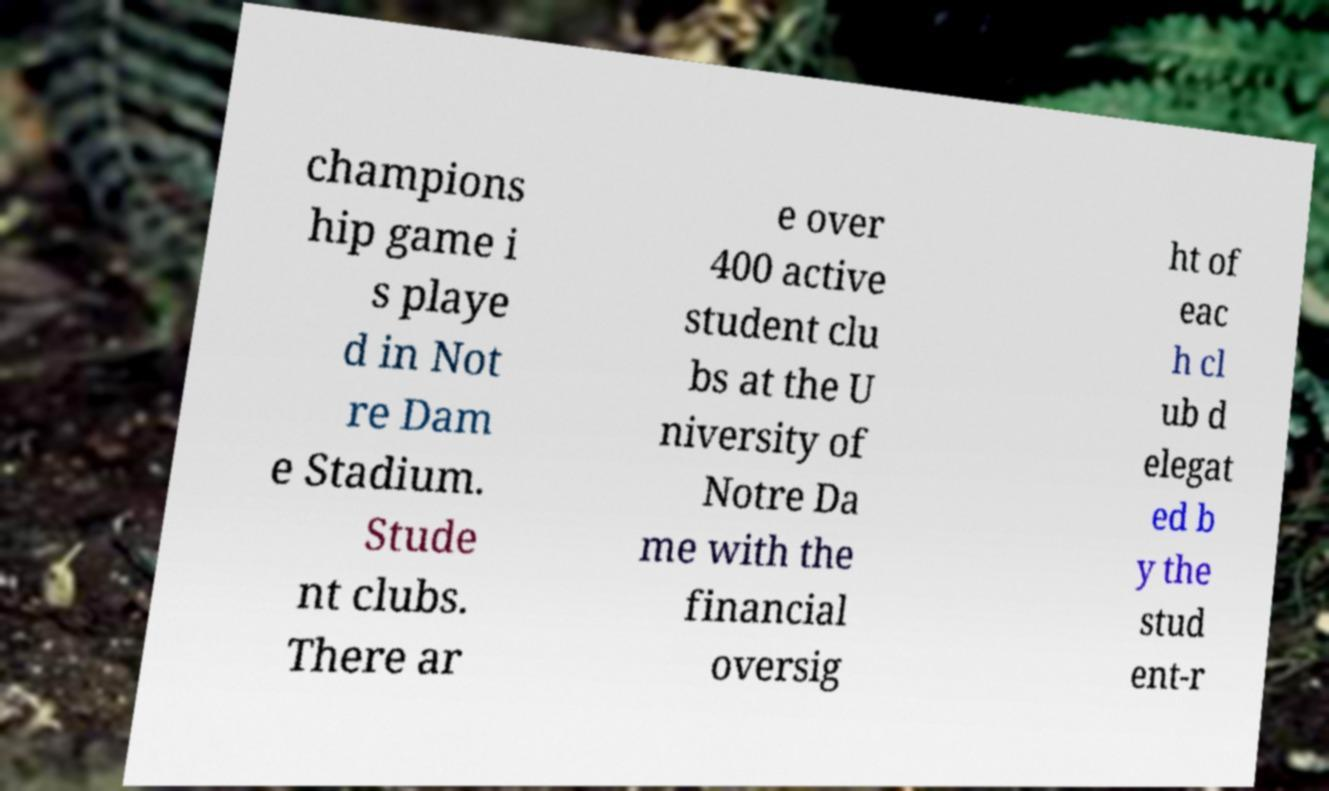Please identify and transcribe the text found in this image. champions hip game i s playe d in Not re Dam e Stadium. Stude nt clubs. There ar e over 400 active student clu bs at the U niversity of Notre Da me with the financial oversig ht of eac h cl ub d elegat ed b y the stud ent-r 